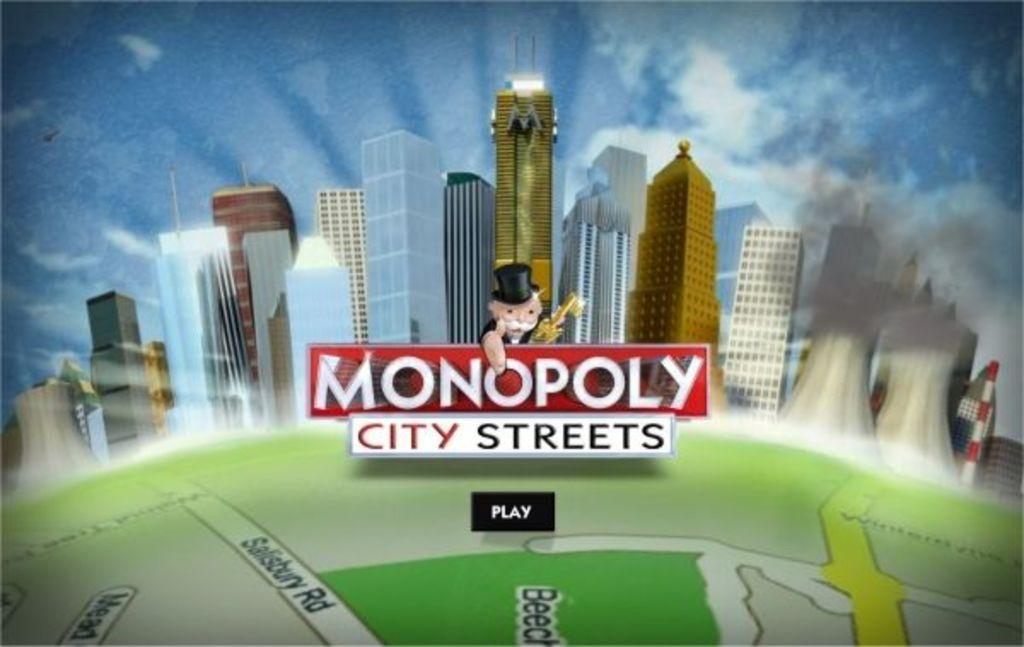Can you describe this image briefly? In this image we can see a picture. In the picture there are skyscrapers, sky with clouds, map and a person holding a flag in his hand. 